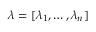Convert formula to latex. <formula><loc_0><loc_0><loc_500><loc_500>\boldsymbol \lambda = [ \lambda _ { 1 } , \dots , \lambda _ { n } ]</formula> 